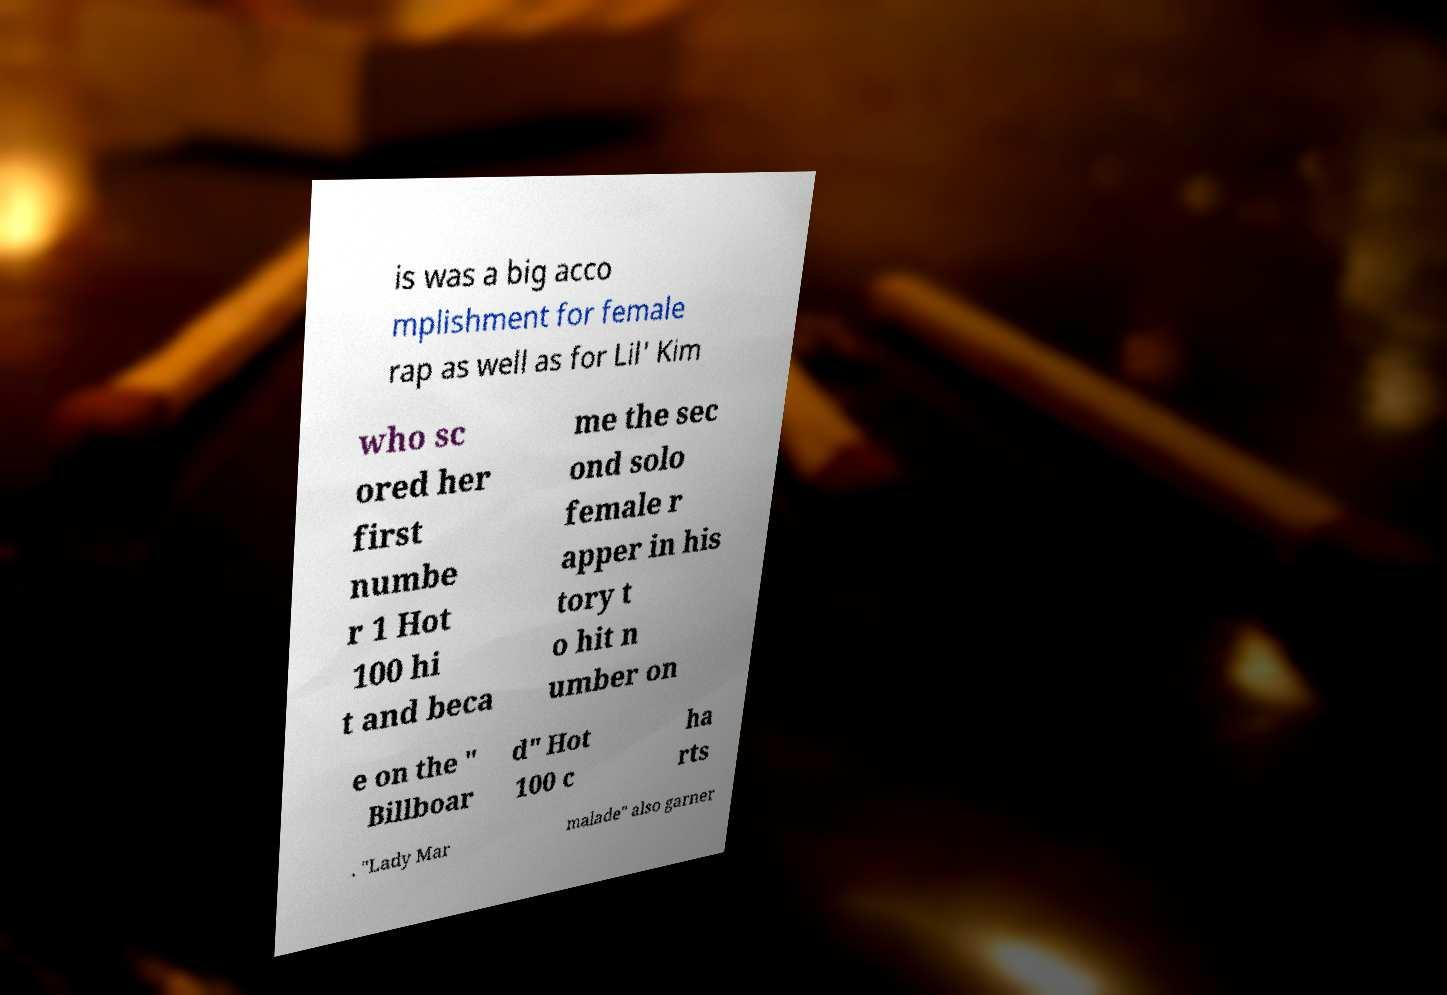Could you extract and type out the text from this image? is was a big acco mplishment for female rap as well as for Lil' Kim who sc ored her first numbe r 1 Hot 100 hi t and beca me the sec ond solo female r apper in his tory t o hit n umber on e on the " Billboar d" Hot 100 c ha rts . "Lady Mar malade" also garner 